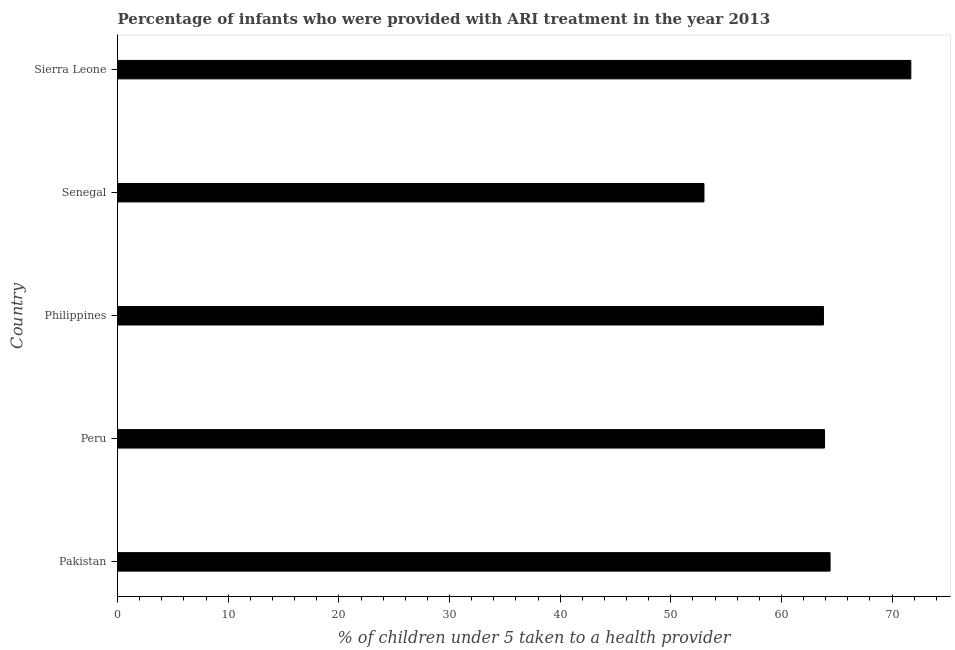Does the graph contain any zero values?
Ensure brevity in your answer.  No. Does the graph contain grids?
Offer a terse response. No. What is the title of the graph?
Offer a very short reply. Percentage of infants who were provided with ARI treatment in the year 2013. What is the label or title of the X-axis?
Give a very brief answer. % of children under 5 taken to a health provider. What is the percentage of children who were provided with ari treatment in Peru?
Offer a terse response. 63.9. Across all countries, what is the maximum percentage of children who were provided with ari treatment?
Your response must be concise. 71.7. In which country was the percentage of children who were provided with ari treatment maximum?
Give a very brief answer. Sierra Leone. In which country was the percentage of children who were provided with ari treatment minimum?
Your response must be concise. Senegal. What is the sum of the percentage of children who were provided with ari treatment?
Ensure brevity in your answer.  316.8. What is the difference between the percentage of children who were provided with ari treatment in Senegal and Sierra Leone?
Keep it short and to the point. -18.7. What is the average percentage of children who were provided with ari treatment per country?
Offer a very short reply. 63.36. What is the median percentage of children who were provided with ari treatment?
Keep it short and to the point. 63.9. In how many countries, is the percentage of children who were provided with ari treatment greater than 10 %?
Provide a short and direct response. 5. What is the ratio of the percentage of children who were provided with ari treatment in Peru to that in Sierra Leone?
Your answer should be compact. 0.89. Is the percentage of children who were provided with ari treatment in Philippines less than that in Sierra Leone?
Provide a short and direct response. Yes. How many bars are there?
Offer a very short reply. 5. What is the difference between two consecutive major ticks on the X-axis?
Give a very brief answer. 10. What is the % of children under 5 taken to a health provider in Pakistan?
Your answer should be very brief. 64.4. What is the % of children under 5 taken to a health provider of Peru?
Keep it short and to the point. 63.9. What is the % of children under 5 taken to a health provider in Philippines?
Provide a succinct answer. 63.8. What is the % of children under 5 taken to a health provider in Sierra Leone?
Make the answer very short. 71.7. What is the difference between the % of children under 5 taken to a health provider in Pakistan and Peru?
Make the answer very short. 0.5. What is the difference between the % of children under 5 taken to a health provider in Pakistan and Senegal?
Provide a succinct answer. 11.4. What is the difference between the % of children under 5 taken to a health provider in Peru and Philippines?
Provide a short and direct response. 0.1. What is the difference between the % of children under 5 taken to a health provider in Peru and Senegal?
Provide a short and direct response. 10.9. What is the difference between the % of children under 5 taken to a health provider in Philippines and Senegal?
Your answer should be compact. 10.8. What is the difference between the % of children under 5 taken to a health provider in Senegal and Sierra Leone?
Your response must be concise. -18.7. What is the ratio of the % of children under 5 taken to a health provider in Pakistan to that in Philippines?
Your response must be concise. 1.01. What is the ratio of the % of children under 5 taken to a health provider in Pakistan to that in Senegal?
Your answer should be compact. 1.22. What is the ratio of the % of children under 5 taken to a health provider in Pakistan to that in Sierra Leone?
Ensure brevity in your answer.  0.9. What is the ratio of the % of children under 5 taken to a health provider in Peru to that in Senegal?
Give a very brief answer. 1.21. What is the ratio of the % of children under 5 taken to a health provider in Peru to that in Sierra Leone?
Make the answer very short. 0.89. What is the ratio of the % of children under 5 taken to a health provider in Philippines to that in Senegal?
Make the answer very short. 1.2. What is the ratio of the % of children under 5 taken to a health provider in Philippines to that in Sierra Leone?
Ensure brevity in your answer.  0.89. What is the ratio of the % of children under 5 taken to a health provider in Senegal to that in Sierra Leone?
Provide a succinct answer. 0.74. 